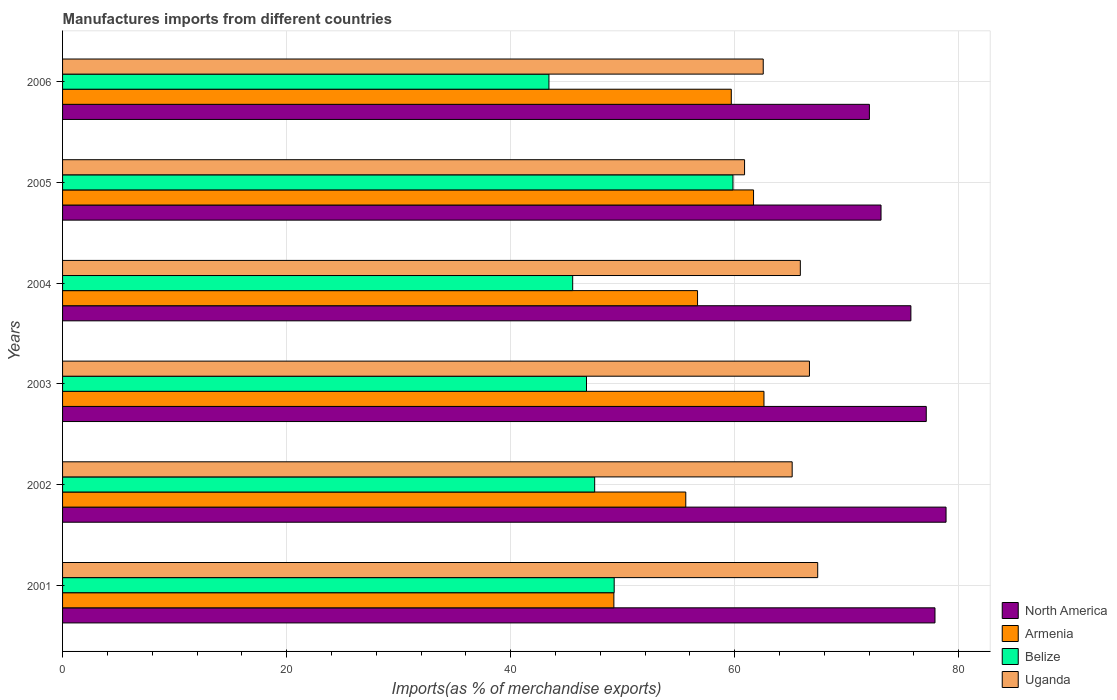How many different coloured bars are there?
Your answer should be compact. 4. How many groups of bars are there?
Ensure brevity in your answer.  6. What is the percentage of imports to different countries in Armenia in 2006?
Provide a short and direct response. 59.7. Across all years, what is the maximum percentage of imports to different countries in Armenia?
Offer a terse response. 62.61. Across all years, what is the minimum percentage of imports to different countries in North America?
Offer a very short reply. 72.02. In which year was the percentage of imports to different countries in Armenia maximum?
Ensure brevity in your answer.  2003. What is the total percentage of imports to different countries in Belize in the graph?
Your answer should be compact. 292.31. What is the difference between the percentage of imports to different countries in North America in 2003 and that in 2005?
Offer a terse response. 4.04. What is the difference between the percentage of imports to different countries in Uganda in 2005 and the percentage of imports to different countries in Armenia in 2002?
Offer a terse response. 5.25. What is the average percentage of imports to different countries in Belize per year?
Offer a terse response. 48.72. In the year 2004, what is the difference between the percentage of imports to different countries in North America and percentage of imports to different countries in Belize?
Your answer should be compact. 30.19. In how many years, is the percentage of imports to different countries in Belize greater than 12 %?
Your response must be concise. 6. What is the ratio of the percentage of imports to different countries in Uganda in 2002 to that in 2006?
Ensure brevity in your answer.  1.04. What is the difference between the highest and the second highest percentage of imports to different countries in Uganda?
Ensure brevity in your answer.  0.74. What is the difference between the highest and the lowest percentage of imports to different countries in Armenia?
Your answer should be very brief. 13.4. In how many years, is the percentage of imports to different countries in North America greater than the average percentage of imports to different countries in North America taken over all years?
Your answer should be compact. 3. What does the 2nd bar from the top in 2005 represents?
Ensure brevity in your answer.  Belize. What does the 1st bar from the bottom in 2005 represents?
Ensure brevity in your answer.  North America. Is it the case that in every year, the sum of the percentage of imports to different countries in Belize and percentage of imports to different countries in Uganda is greater than the percentage of imports to different countries in Armenia?
Offer a terse response. Yes. Are all the bars in the graph horizontal?
Offer a very short reply. Yes. How many years are there in the graph?
Make the answer very short. 6. What is the difference between two consecutive major ticks on the X-axis?
Offer a terse response. 20. How many legend labels are there?
Your answer should be compact. 4. What is the title of the graph?
Provide a succinct answer. Manufactures imports from different countries. What is the label or title of the X-axis?
Provide a succinct answer. Imports(as % of merchandise exports). What is the label or title of the Y-axis?
Give a very brief answer. Years. What is the Imports(as % of merchandise exports) in North America in 2001?
Your answer should be compact. 77.88. What is the Imports(as % of merchandise exports) of Armenia in 2001?
Provide a short and direct response. 49.21. What is the Imports(as % of merchandise exports) in Belize in 2001?
Keep it short and to the point. 49.24. What is the Imports(as % of merchandise exports) in Uganda in 2001?
Your response must be concise. 67.41. What is the Imports(as % of merchandise exports) in North America in 2002?
Your answer should be compact. 78.87. What is the Imports(as % of merchandise exports) of Armenia in 2002?
Keep it short and to the point. 55.63. What is the Imports(as % of merchandise exports) of Belize in 2002?
Ensure brevity in your answer.  47.5. What is the Imports(as % of merchandise exports) of Uganda in 2002?
Offer a very short reply. 65.13. What is the Imports(as % of merchandise exports) in North America in 2003?
Provide a short and direct response. 77.1. What is the Imports(as % of merchandise exports) of Armenia in 2003?
Your answer should be compact. 62.61. What is the Imports(as % of merchandise exports) in Belize in 2003?
Provide a short and direct response. 46.77. What is the Imports(as % of merchandise exports) of Uganda in 2003?
Keep it short and to the point. 66.67. What is the Imports(as % of merchandise exports) of North America in 2004?
Offer a very short reply. 75.73. What is the Imports(as % of merchandise exports) in Armenia in 2004?
Give a very brief answer. 56.68. What is the Imports(as % of merchandise exports) of Belize in 2004?
Your answer should be very brief. 45.54. What is the Imports(as % of merchandise exports) of Uganda in 2004?
Ensure brevity in your answer.  65.86. What is the Imports(as % of merchandise exports) of North America in 2005?
Keep it short and to the point. 73.06. What is the Imports(as % of merchandise exports) in Armenia in 2005?
Your answer should be compact. 61.68. What is the Imports(as % of merchandise exports) of Belize in 2005?
Your answer should be very brief. 59.85. What is the Imports(as % of merchandise exports) in Uganda in 2005?
Offer a terse response. 60.88. What is the Imports(as % of merchandise exports) in North America in 2006?
Give a very brief answer. 72.02. What is the Imports(as % of merchandise exports) in Armenia in 2006?
Your response must be concise. 59.7. What is the Imports(as % of merchandise exports) in Belize in 2006?
Your answer should be compact. 43.42. What is the Imports(as % of merchandise exports) of Uganda in 2006?
Your response must be concise. 62.55. Across all years, what is the maximum Imports(as % of merchandise exports) in North America?
Your answer should be compact. 78.87. Across all years, what is the maximum Imports(as % of merchandise exports) of Armenia?
Offer a terse response. 62.61. Across all years, what is the maximum Imports(as % of merchandise exports) of Belize?
Provide a succinct answer. 59.85. Across all years, what is the maximum Imports(as % of merchandise exports) in Uganda?
Your answer should be compact. 67.41. Across all years, what is the minimum Imports(as % of merchandise exports) in North America?
Your response must be concise. 72.02. Across all years, what is the minimum Imports(as % of merchandise exports) in Armenia?
Offer a very short reply. 49.21. Across all years, what is the minimum Imports(as % of merchandise exports) in Belize?
Offer a terse response. 43.42. Across all years, what is the minimum Imports(as % of merchandise exports) in Uganda?
Provide a short and direct response. 60.88. What is the total Imports(as % of merchandise exports) of North America in the graph?
Offer a terse response. 454.66. What is the total Imports(as % of merchandise exports) of Armenia in the graph?
Make the answer very short. 345.52. What is the total Imports(as % of merchandise exports) of Belize in the graph?
Provide a succinct answer. 292.31. What is the total Imports(as % of merchandise exports) in Uganda in the graph?
Your response must be concise. 388.5. What is the difference between the Imports(as % of merchandise exports) of North America in 2001 and that in 2002?
Your answer should be compact. -0.99. What is the difference between the Imports(as % of merchandise exports) of Armenia in 2001 and that in 2002?
Offer a very short reply. -6.42. What is the difference between the Imports(as % of merchandise exports) of Belize in 2001 and that in 2002?
Make the answer very short. 1.74. What is the difference between the Imports(as % of merchandise exports) in Uganda in 2001 and that in 2002?
Your answer should be compact. 2.28. What is the difference between the Imports(as % of merchandise exports) in North America in 2001 and that in 2003?
Provide a short and direct response. 0.78. What is the difference between the Imports(as % of merchandise exports) of Armenia in 2001 and that in 2003?
Your response must be concise. -13.4. What is the difference between the Imports(as % of merchandise exports) of Belize in 2001 and that in 2003?
Offer a very short reply. 2.47. What is the difference between the Imports(as % of merchandise exports) of Uganda in 2001 and that in 2003?
Your response must be concise. 0.74. What is the difference between the Imports(as % of merchandise exports) of North America in 2001 and that in 2004?
Offer a very short reply. 2.15. What is the difference between the Imports(as % of merchandise exports) in Armenia in 2001 and that in 2004?
Your response must be concise. -7.47. What is the difference between the Imports(as % of merchandise exports) of Belize in 2001 and that in 2004?
Your answer should be very brief. 3.71. What is the difference between the Imports(as % of merchandise exports) of Uganda in 2001 and that in 2004?
Offer a terse response. 1.55. What is the difference between the Imports(as % of merchandise exports) of North America in 2001 and that in 2005?
Your answer should be very brief. 4.82. What is the difference between the Imports(as % of merchandise exports) of Armenia in 2001 and that in 2005?
Offer a very short reply. -12.47. What is the difference between the Imports(as % of merchandise exports) in Belize in 2001 and that in 2005?
Ensure brevity in your answer.  -10.6. What is the difference between the Imports(as % of merchandise exports) in Uganda in 2001 and that in 2005?
Offer a terse response. 6.53. What is the difference between the Imports(as % of merchandise exports) in North America in 2001 and that in 2006?
Offer a very short reply. 5.85. What is the difference between the Imports(as % of merchandise exports) in Armenia in 2001 and that in 2006?
Offer a very short reply. -10.48. What is the difference between the Imports(as % of merchandise exports) in Belize in 2001 and that in 2006?
Offer a terse response. 5.83. What is the difference between the Imports(as % of merchandise exports) in Uganda in 2001 and that in 2006?
Give a very brief answer. 4.86. What is the difference between the Imports(as % of merchandise exports) in North America in 2002 and that in 2003?
Provide a short and direct response. 1.77. What is the difference between the Imports(as % of merchandise exports) in Armenia in 2002 and that in 2003?
Make the answer very short. -6.98. What is the difference between the Imports(as % of merchandise exports) of Belize in 2002 and that in 2003?
Ensure brevity in your answer.  0.73. What is the difference between the Imports(as % of merchandise exports) in Uganda in 2002 and that in 2003?
Your answer should be very brief. -1.54. What is the difference between the Imports(as % of merchandise exports) in North America in 2002 and that in 2004?
Offer a very short reply. 3.14. What is the difference between the Imports(as % of merchandise exports) in Armenia in 2002 and that in 2004?
Make the answer very short. -1.05. What is the difference between the Imports(as % of merchandise exports) in Belize in 2002 and that in 2004?
Offer a terse response. 1.96. What is the difference between the Imports(as % of merchandise exports) of Uganda in 2002 and that in 2004?
Your answer should be very brief. -0.73. What is the difference between the Imports(as % of merchandise exports) in North America in 2002 and that in 2005?
Your answer should be compact. 5.8. What is the difference between the Imports(as % of merchandise exports) in Armenia in 2002 and that in 2005?
Your answer should be very brief. -6.05. What is the difference between the Imports(as % of merchandise exports) of Belize in 2002 and that in 2005?
Give a very brief answer. -12.34. What is the difference between the Imports(as % of merchandise exports) of Uganda in 2002 and that in 2005?
Provide a succinct answer. 4.25. What is the difference between the Imports(as % of merchandise exports) of North America in 2002 and that in 2006?
Offer a terse response. 6.84. What is the difference between the Imports(as % of merchandise exports) of Armenia in 2002 and that in 2006?
Give a very brief answer. -4.06. What is the difference between the Imports(as % of merchandise exports) of Belize in 2002 and that in 2006?
Ensure brevity in your answer.  4.08. What is the difference between the Imports(as % of merchandise exports) of Uganda in 2002 and that in 2006?
Give a very brief answer. 2.58. What is the difference between the Imports(as % of merchandise exports) in North America in 2003 and that in 2004?
Keep it short and to the point. 1.37. What is the difference between the Imports(as % of merchandise exports) of Armenia in 2003 and that in 2004?
Offer a terse response. 5.93. What is the difference between the Imports(as % of merchandise exports) of Belize in 2003 and that in 2004?
Your response must be concise. 1.23. What is the difference between the Imports(as % of merchandise exports) of Uganda in 2003 and that in 2004?
Give a very brief answer. 0.82. What is the difference between the Imports(as % of merchandise exports) in North America in 2003 and that in 2005?
Provide a short and direct response. 4.04. What is the difference between the Imports(as % of merchandise exports) of Armenia in 2003 and that in 2005?
Your answer should be compact. 0.93. What is the difference between the Imports(as % of merchandise exports) of Belize in 2003 and that in 2005?
Offer a terse response. -13.07. What is the difference between the Imports(as % of merchandise exports) in Uganda in 2003 and that in 2005?
Your answer should be compact. 5.79. What is the difference between the Imports(as % of merchandise exports) of North America in 2003 and that in 2006?
Give a very brief answer. 5.08. What is the difference between the Imports(as % of merchandise exports) in Armenia in 2003 and that in 2006?
Offer a terse response. 2.92. What is the difference between the Imports(as % of merchandise exports) of Belize in 2003 and that in 2006?
Offer a very short reply. 3.35. What is the difference between the Imports(as % of merchandise exports) in Uganda in 2003 and that in 2006?
Ensure brevity in your answer.  4.13. What is the difference between the Imports(as % of merchandise exports) of North America in 2004 and that in 2005?
Offer a very short reply. 2.67. What is the difference between the Imports(as % of merchandise exports) in Armenia in 2004 and that in 2005?
Give a very brief answer. -5. What is the difference between the Imports(as % of merchandise exports) in Belize in 2004 and that in 2005?
Offer a very short reply. -14.31. What is the difference between the Imports(as % of merchandise exports) of Uganda in 2004 and that in 2005?
Keep it short and to the point. 4.98. What is the difference between the Imports(as % of merchandise exports) of North America in 2004 and that in 2006?
Offer a terse response. 3.7. What is the difference between the Imports(as % of merchandise exports) of Armenia in 2004 and that in 2006?
Provide a succinct answer. -3.01. What is the difference between the Imports(as % of merchandise exports) of Belize in 2004 and that in 2006?
Your response must be concise. 2.12. What is the difference between the Imports(as % of merchandise exports) in Uganda in 2004 and that in 2006?
Provide a succinct answer. 3.31. What is the difference between the Imports(as % of merchandise exports) of North America in 2005 and that in 2006?
Make the answer very short. 1.04. What is the difference between the Imports(as % of merchandise exports) in Armenia in 2005 and that in 2006?
Provide a short and direct response. 1.99. What is the difference between the Imports(as % of merchandise exports) in Belize in 2005 and that in 2006?
Provide a succinct answer. 16.43. What is the difference between the Imports(as % of merchandise exports) in Uganda in 2005 and that in 2006?
Offer a terse response. -1.67. What is the difference between the Imports(as % of merchandise exports) of North America in 2001 and the Imports(as % of merchandise exports) of Armenia in 2002?
Give a very brief answer. 22.25. What is the difference between the Imports(as % of merchandise exports) in North America in 2001 and the Imports(as % of merchandise exports) in Belize in 2002?
Ensure brevity in your answer.  30.38. What is the difference between the Imports(as % of merchandise exports) in North America in 2001 and the Imports(as % of merchandise exports) in Uganda in 2002?
Provide a short and direct response. 12.75. What is the difference between the Imports(as % of merchandise exports) in Armenia in 2001 and the Imports(as % of merchandise exports) in Belize in 2002?
Keep it short and to the point. 1.71. What is the difference between the Imports(as % of merchandise exports) in Armenia in 2001 and the Imports(as % of merchandise exports) in Uganda in 2002?
Provide a short and direct response. -15.92. What is the difference between the Imports(as % of merchandise exports) in Belize in 2001 and the Imports(as % of merchandise exports) in Uganda in 2002?
Make the answer very short. -15.89. What is the difference between the Imports(as % of merchandise exports) in North America in 2001 and the Imports(as % of merchandise exports) in Armenia in 2003?
Ensure brevity in your answer.  15.27. What is the difference between the Imports(as % of merchandise exports) in North America in 2001 and the Imports(as % of merchandise exports) in Belize in 2003?
Offer a very short reply. 31.11. What is the difference between the Imports(as % of merchandise exports) in North America in 2001 and the Imports(as % of merchandise exports) in Uganda in 2003?
Your answer should be very brief. 11.21. What is the difference between the Imports(as % of merchandise exports) of Armenia in 2001 and the Imports(as % of merchandise exports) of Belize in 2003?
Your response must be concise. 2.44. What is the difference between the Imports(as % of merchandise exports) of Armenia in 2001 and the Imports(as % of merchandise exports) of Uganda in 2003?
Keep it short and to the point. -17.46. What is the difference between the Imports(as % of merchandise exports) of Belize in 2001 and the Imports(as % of merchandise exports) of Uganda in 2003?
Keep it short and to the point. -17.43. What is the difference between the Imports(as % of merchandise exports) of North America in 2001 and the Imports(as % of merchandise exports) of Armenia in 2004?
Your answer should be compact. 21.2. What is the difference between the Imports(as % of merchandise exports) in North America in 2001 and the Imports(as % of merchandise exports) in Belize in 2004?
Provide a short and direct response. 32.34. What is the difference between the Imports(as % of merchandise exports) in North America in 2001 and the Imports(as % of merchandise exports) in Uganda in 2004?
Keep it short and to the point. 12.02. What is the difference between the Imports(as % of merchandise exports) in Armenia in 2001 and the Imports(as % of merchandise exports) in Belize in 2004?
Your answer should be very brief. 3.68. What is the difference between the Imports(as % of merchandise exports) in Armenia in 2001 and the Imports(as % of merchandise exports) in Uganda in 2004?
Give a very brief answer. -16.64. What is the difference between the Imports(as % of merchandise exports) of Belize in 2001 and the Imports(as % of merchandise exports) of Uganda in 2004?
Ensure brevity in your answer.  -16.62. What is the difference between the Imports(as % of merchandise exports) in North America in 2001 and the Imports(as % of merchandise exports) in Armenia in 2005?
Provide a succinct answer. 16.2. What is the difference between the Imports(as % of merchandise exports) in North America in 2001 and the Imports(as % of merchandise exports) in Belize in 2005?
Make the answer very short. 18.03. What is the difference between the Imports(as % of merchandise exports) in North America in 2001 and the Imports(as % of merchandise exports) in Uganda in 2005?
Ensure brevity in your answer.  17. What is the difference between the Imports(as % of merchandise exports) in Armenia in 2001 and the Imports(as % of merchandise exports) in Belize in 2005?
Keep it short and to the point. -10.63. What is the difference between the Imports(as % of merchandise exports) of Armenia in 2001 and the Imports(as % of merchandise exports) of Uganda in 2005?
Offer a terse response. -11.67. What is the difference between the Imports(as % of merchandise exports) of Belize in 2001 and the Imports(as % of merchandise exports) of Uganda in 2005?
Your answer should be compact. -11.64. What is the difference between the Imports(as % of merchandise exports) of North America in 2001 and the Imports(as % of merchandise exports) of Armenia in 2006?
Make the answer very short. 18.18. What is the difference between the Imports(as % of merchandise exports) of North America in 2001 and the Imports(as % of merchandise exports) of Belize in 2006?
Your answer should be compact. 34.46. What is the difference between the Imports(as % of merchandise exports) of North America in 2001 and the Imports(as % of merchandise exports) of Uganda in 2006?
Provide a succinct answer. 15.33. What is the difference between the Imports(as % of merchandise exports) of Armenia in 2001 and the Imports(as % of merchandise exports) of Belize in 2006?
Offer a very short reply. 5.8. What is the difference between the Imports(as % of merchandise exports) in Armenia in 2001 and the Imports(as % of merchandise exports) in Uganda in 2006?
Make the answer very short. -13.33. What is the difference between the Imports(as % of merchandise exports) in Belize in 2001 and the Imports(as % of merchandise exports) in Uganda in 2006?
Offer a terse response. -13.3. What is the difference between the Imports(as % of merchandise exports) of North America in 2002 and the Imports(as % of merchandise exports) of Armenia in 2003?
Your answer should be compact. 16.25. What is the difference between the Imports(as % of merchandise exports) of North America in 2002 and the Imports(as % of merchandise exports) of Belize in 2003?
Your answer should be very brief. 32.1. What is the difference between the Imports(as % of merchandise exports) in North America in 2002 and the Imports(as % of merchandise exports) in Uganda in 2003?
Provide a short and direct response. 12.19. What is the difference between the Imports(as % of merchandise exports) in Armenia in 2002 and the Imports(as % of merchandise exports) in Belize in 2003?
Your response must be concise. 8.86. What is the difference between the Imports(as % of merchandise exports) of Armenia in 2002 and the Imports(as % of merchandise exports) of Uganda in 2003?
Provide a short and direct response. -11.04. What is the difference between the Imports(as % of merchandise exports) of Belize in 2002 and the Imports(as % of merchandise exports) of Uganda in 2003?
Ensure brevity in your answer.  -19.17. What is the difference between the Imports(as % of merchandise exports) of North America in 2002 and the Imports(as % of merchandise exports) of Armenia in 2004?
Offer a very short reply. 22.18. What is the difference between the Imports(as % of merchandise exports) of North America in 2002 and the Imports(as % of merchandise exports) of Belize in 2004?
Your answer should be compact. 33.33. What is the difference between the Imports(as % of merchandise exports) in North America in 2002 and the Imports(as % of merchandise exports) in Uganda in 2004?
Make the answer very short. 13.01. What is the difference between the Imports(as % of merchandise exports) in Armenia in 2002 and the Imports(as % of merchandise exports) in Belize in 2004?
Offer a very short reply. 10.1. What is the difference between the Imports(as % of merchandise exports) of Armenia in 2002 and the Imports(as % of merchandise exports) of Uganda in 2004?
Your response must be concise. -10.23. What is the difference between the Imports(as % of merchandise exports) of Belize in 2002 and the Imports(as % of merchandise exports) of Uganda in 2004?
Your response must be concise. -18.36. What is the difference between the Imports(as % of merchandise exports) in North America in 2002 and the Imports(as % of merchandise exports) in Armenia in 2005?
Make the answer very short. 17.18. What is the difference between the Imports(as % of merchandise exports) of North America in 2002 and the Imports(as % of merchandise exports) of Belize in 2005?
Keep it short and to the point. 19.02. What is the difference between the Imports(as % of merchandise exports) of North America in 2002 and the Imports(as % of merchandise exports) of Uganda in 2005?
Ensure brevity in your answer.  17.99. What is the difference between the Imports(as % of merchandise exports) in Armenia in 2002 and the Imports(as % of merchandise exports) in Belize in 2005?
Make the answer very short. -4.21. What is the difference between the Imports(as % of merchandise exports) in Armenia in 2002 and the Imports(as % of merchandise exports) in Uganda in 2005?
Provide a short and direct response. -5.25. What is the difference between the Imports(as % of merchandise exports) of Belize in 2002 and the Imports(as % of merchandise exports) of Uganda in 2005?
Provide a succinct answer. -13.38. What is the difference between the Imports(as % of merchandise exports) in North America in 2002 and the Imports(as % of merchandise exports) in Armenia in 2006?
Offer a terse response. 19.17. What is the difference between the Imports(as % of merchandise exports) in North America in 2002 and the Imports(as % of merchandise exports) in Belize in 2006?
Provide a short and direct response. 35.45. What is the difference between the Imports(as % of merchandise exports) in North America in 2002 and the Imports(as % of merchandise exports) in Uganda in 2006?
Provide a succinct answer. 16.32. What is the difference between the Imports(as % of merchandise exports) in Armenia in 2002 and the Imports(as % of merchandise exports) in Belize in 2006?
Your response must be concise. 12.22. What is the difference between the Imports(as % of merchandise exports) of Armenia in 2002 and the Imports(as % of merchandise exports) of Uganda in 2006?
Provide a succinct answer. -6.91. What is the difference between the Imports(as % of merchandise exports) of Belize in 2002 and the Imports(as % of merchandise exports) of Uganda in 2006?
Keep it short and to the point. -15.05. What is the difference between the Imports(as % of merchandise exports) in North America in 2003 and the Imports(as % of merchandise exports) in Armenia in 2004?
Offer a very short reply. 20.42. What is the difference between the Imports(as % of merchandise exports) of North America in 2003 and the Imports(as % of merchandise exports) of Belize in 2004?
Offer a terse response. 31.56. What is the difference between the Imports(as % of merchandise exports) in North America in 2003 and the Imports(as % of merchandise exports) in Uganda in 2004?
Your answer should be very brief. 11.24. What is the difference between the Imports(as % of merchandise exports) in Armenia in 2003 and the Imports(as % of merchandise exports) in Belize in 2004?
Your answer should be very brief. 17.08. What is the difference between the Imports(as % of merchandise exports) of Armenia in 2003 and the Imports(as % of merchandise exports) of Uganda in 2004?
Your response must be concise. -3.24. What is the difference between the Imports(as % of merchandise exports) of Belize in 2003 and the Imports(as % of merchandise exports) of Uganda in 2004?
Your response must be concise. -19.09. What is the difference between the Imports(as % of merchandise exports) in North America in 2003 and the Imports(as % of merchandise exports) in Armenia in 2005?
Your response must be concise. 15.42. What is the difference between the Imports(as % of merchandise exports) in North America in 2003 and the Imports(as % of merchandise exports) in Belize in 2005?
Make the answer very short. 17.26. What is the difference between the Imports(as % of merchandise exports) in North America in 2003 and the Imports(as % of merchandise exports) in Uganda in 2005?
Your answer should be compact. 16.22. What is the difference between the Imports(as % of merchandise exports) in Armenia in 2003 and the Imports(as % of merchandise exports) in Belize in 2005?
Your response must be concise. 2.77. What is the difference between the Imports(as % of merchandise exports) of Armenia in 2003 and the Imports(as % of merchandise exports) of Uganda in 2005?
Provide a succinct answer. 1.73. What is the difference between the Imports(as % of merchandise exports) in Belize in 2003 and the Imports(as % of merchandise exports) in Uganda in 2005?
Offer a terse response. -14.11. What is the difference between the Imports(as % of merchandise exports) in North America in 2003 and the Imports(as % of merchandise exports) in Armenia in 2006?
Give a very brief answer. 17.4. What is the difference between the Imports(as % of merchandise exports) of North America in 2003 and the Imports(as % of merchandise exports) of Belize in 2006?
Your response must be concise. 33.68. What is the difference between the Imports(as % of merchandise exports) of North America in 2003 and the Imports(as % of merchandise exports) of Uganda in 2006?
Make the answer very short. 14.55. What is the difference between the Imports(as % of merchandise exports) of Armenia in 2003 and the Imports(as % of merchandise exports) of Belize in 2006?
Make the answer very short. 19.2. What is the difference between the Imports(as % of merchandise exports) in Armenia in 2003 and the Imports(as % of merchandise exports) in Uganda in 2006?
Your answer should be very brief. 0.07. What is the difference between the Imports(as % of merchandise exports) of Belize in 2003 and the Imports(as % of merchandise exports) of Uganda in 2006?
Ensure brevity in your answer.  -15.78. What is the difference between the Imports(as % of merchandise exports) in North America in 2004 and the Imports(as % of merchandise exports) in Armenia in 2005?
Ensure brevity in your answer.  14.05. What is the difference between the Imports(as % of merchandise exports) of North America in 2004 and the Imports(as % of merchandise exports) of Belize in 2005?
Make the answer very short. 15.88. What is the difference between the Imports(as % of merchandise exports) in North America in 2004 and the Imports(as % of merchandise exports) in Uganda in 2005?
Your answer should be very brief. 14.85. What is the difference between the Imports(as % of merchandise exports) in Armenia in 2004 and the Imports(as % of merchandise exports) in Belize in 2005?
Your answer should be very brief. -3.16. What is the difference between the Imports(as % of merchandise exports) of Armenia in 2004 and the Imports(as % of merchandise exports) of Uganda in 2005?
Give a very brief answer. -4.2. What is the difference between the Imports(as % of merchandise exports) in Belize in 2004 and the Imports(as % of merchandise exports) in Uganda in 2005?
Provide a short and direct response. -15.34. What is the difference between the Imports(as % of merchandise exports) in North America in 2004 and the Imports(as % of merchandise exports) in Armenia in 2006?
Keep it short and to the point. 16.03. What is the difference between the Imports(as % of merchandise exports) in North America in 2004 and the Imports(as % of merchandise exports) in Belize in 2006?
Provide a succinct answer. 32.31. What is the difference between the Imports(as % of merchandise exports) of North America in 2004 and the Imports(as % of merchandise exports) of Uganda in 2006?
Offer a very short reply. 13.18. What is the difference between the Imports(as % of merchandise exports) in Armenia in 2004 and the Imports(as % of merchandise exports) in Belize in 2006?
Make the answer very short. 13.27. What is the difference between the Imports(as % of merchandise exports) of Armenia in 2004 and the Imports(as % of merchandise exports) of Uganda in 2006?
Make the answer very short. -5.86. What is the difference between the Imports(as % of merchandise exports) of Belize in 2004 and the Imports(as % of merchandise exports) of Uganda in 2006?
Provide a short and direct response. -17.01. What is the difference between the Imports(as % of merchandise exports) of North America in 2005 and the Imports(as % of merchandise exports) of Armenia in 2006?
Offer a terse response. 13.37. What is the difference between the Imports(as % of merchandise exports) of North America in 2005 and the Imports(as % of merchandise exports) of Belize in 2006?
Keep it short and to the point. 29.65. What is the difference between the Imports(as % of merchandise exports) in North America in 2005 and the Imports(as % of merchandise exports) in Uganda in 2006?
Your answer should be very brief. 10.52. What is the difference between the Imports(as % of merchandise exports) in Armenia in 2005 and the Imports(as % of merchandise exports) in Belize in 2006?
Give a very brief answer. 18.26. What is the difference between the Imports(as % of merchandise exports) of Armenia in 2005 and the Imports(as % of merchandise exports) of Uganda in 2006?
Offer a very short reply. -0.87. What is the difference between the Imports(as % of merchandise exports) in Belize in 2005 and the Imports(as % of merchandise exports) in Uganda in 2006?
Make the answer very short. -2.7. What is the average Imports(as % of merchandise exports) of North America per year?
Offer a terse response. 75.78. What is the average Imports(as % of merchandise exports) in Armenia per year?
Your response must be concise. 57.59. What is the average Imports(as % of merchandise exports) of Belize per year?
Your answer should be compact. 48.72. What is the average Imports(as % of merchandise exports) in Uganda per year?
Your answer should be compact. 64.75. In the year 2001, what is the difference between the Imports(as % of merchandise exports) of North America and Imports(as % of merchandise exports) of Armenia?
Your answer should be very brief. 28.66. In the year 2001, what is the difference between the Imports(as % of merchandise exports) in North America and Imports(as % of merchandise exports) in Belize?
Provide a succinct answer. 28.64. In the year 2001, what is the difference between the Imports(as % of merchandise exports) in North America and Imports(as % of merchandise exports) in Uganda?
Your response must be concise. 10.47. In the year 2001, what is the difference between the Imports(as % of merchandise exports) in Armenia and Imports(as % of merchandise exports) in Belize?
Provide a short and direct response. -0.03. In the year 2001, what is the difference between the Imports(as % of merchandise exports) of Armenia and Imports(as % of merchandise exports) of Uganda?
Your answer should be compact. -18.19. In the year 2001, what is the difference between the Imports(as % of merchandise exports) in Belize and Imports(as % of merchandise exports) in Uganda?
Your answer should be very brief. -18.17. In the year 2002, what is the difference between the Imports(as % of merchandise exports) of North America and Imports(as % of merchandise exports) of Armenia?
Offer a very short reply. 23.23. In the year 2002, what is the difference between the Imports(as % of merchandise exports) in North America and Imports(as % of merchandise exports) in Belize?
Your answer should be compact. 31.37. In the year 2002, what is the difference between the Imports(as % of merchandise exports) of North America and Imports(as % of merchandise exports) of Uganda?
Your answer should be very brief. 13.74. In the year 2002, what is the difference between the Imports(as % of merchandise exports) of Armenia and Imports(as % of merchandise exports) of Belize?
Keep it short and to the point. 8.13. In the year 2002, what is the difference between the Imports(as % of merchandise exports) in Armenia and Imports(as % of merchandise exports) in Uganda?
Provide a succinct answer. -9.5. In the year 2002, what is the difference between the Imports(as % of merchandise exports) in Belize and Imports(as % of merchandise exports) in Uganda?
Your response must be concise. -17.63. In the year 2003, what is the difference between the Imports(as % of merchandise exports) of North America and Imports(as % of merchandise exports) of Armenia?
Make the answer very short. 14.49. In the year 2003, what is the difference between the Imports(as % of merchandise exports) of North America and Imports(as % of merchandise exports) of Belize?
Your response must be concise. 30.33. In the year 2003, what is the difference between the Imports(as % of merchandise exports) of North America and Imports(as % of merchandise exports) of Uganda?
Ensure brevity in your answer.  10.43. In the year 2003, what is the difference between the Imports(as % of merchandise exports) of Armenia and Imports(as % of merchandise exports) of Belize?
Provide a short and direct response. 15.84. In the year 2003, what is the difference between the Imports(as % of merchandise exports) of Armenia and Imports(as % of merchandise exports) of Uganda?
Provide a succinct answer. -4.06. In the year 2003, what is the difference between the Imports(as % of merchandise exports) of Belize and Imports(as % of merchandise exports) of Uganda?
Make the answer very short. -19.9. In the year 2004, what is the difference between the Imports(as % of merchandise exports) in North America and Imports(as % of merchandise exports) in Armenia?
Give a very brief answer. 19.05. In the year 2004, what is the difference between the Imports(as % of merchandise exports) in North America and Imports(as % of merchandise exports) in Belize?
Keep it short and to the point. 30.19. In the year 2004, what is the difference between the Imports(as % of merchandise exports) in North America and Imports(as % of merchandise exports) in Uganda?
Keep it short and to the point. 9.87. In the year 2004, what is the difference between the Imports(as % of merchandise exports) of Armenia and Imports(as % of merchandise exports) of Belize?
Offer a very short reply. 11.15. In the year 2004, what is the difference between the Imports(as % of merchandise exports) of Armenia and Imports(as % of merchandise exports) of Uganda?
Provide a succinct answer. -9.18. In the year 2004, what is the difference between the Imports(as % of merchandise exports) of Belize and Imports(as % of merchandise exports) of Uganda?
Your answer should be very brief. -20.32. In the year 2005, what is the difference between the Imports(as % of merchandise exports) of North America and Imports(as % of merchandise exports) of Armenia?
Offer a very short reply. 11.38. In the year 2005, what is the difference between the Imports(as % of merchandise exports) of North America and Imports(as % of merchandise exports) of Belize?
Your answer should be compact. 13.22. In the year 2005, what is the difference between the Imports(as % of merchandise exports) in North America and Imports(as % of merchandise exports) in Uganda?
Your answer should be very brief. 12.18. In the year 2005, what is the difference between the Imports(as % of merchandise exports) of Armenia and Imports(as % of merchandise exports) of Belize?
Offer a terse response. 1.84. In the year 2005, what is the difference between the Imports(as % of merchandise exports) in Armenia and Imports(as % of merchandise exports) in Uganda?
Your response must be concise. 0.8. In the year 2005, what is the difference between the Imports(as % of merchandise exports) of Belize and Imports(as % of merchandise exports) of Uganda?
Provide a succinct answer. -1.04. In the year 2006, what is the difference between the Imports(as % of merchandise exports) of North America and Imports(as % of merchandise exports) of Armenia?
Your answer should be very brief. 12.33. In the year 2006, what is the difference between the Imports(as % of merchandise exports) of North America and Imports(as % of merchandise exports) of Belize?
Provide a succinct answer. 28.61. In the year 2006, what is the difference between the Imports(as % of merchandise exports) in North America and Imports(as % of merchandise exports) in Uganda?
Provide a succinct answer. 9.48. In the year 2006, what is the difference between the Imports(as % of merchandise exports) in Armenia and Imports(as % of merchandise exports) in Belize?
Make the answer very short. 16.28. In the year 2006, what is the difference between the Imports(as % of merchandise exports) in Armenia and Imports(as % of merchandise exports) in Uganda?
Your response must be concise. -2.85. In the year 2006, what is the difference between the Imports(as % of merchandise exports) in Belize and Imports(as % of merchandise exports) in Uganda?
Offer a very short reply. -19.13. What is the ratio of the Imports(as % of merchandise exports) of North America in 2001 to that in 2002?
Make the answer very short. 0.99. What is the ratio of the Imports(as % of merchandise exports) of Armenia in 2001 to that in 2002?
Your answer should be very brief. 0.88. What is the ratio of the Imports(as % of merchandise exports) of Belize in 2001 to that in 2002?
Your answer should be compact. 1.04. What is the ratio of the Imports(as % of merchandise exports) in Uganda in 2001 to that in 2002?
Provide a succinct answer. 1.03. What is the ratio of the Imports(as % of merchandise exports) in Armenia in 2001 to that in 2003?
Offer a very short reply. 0.79. What is the ratio of the Imports(as % of merchandise exports) in Belize in 2001 to that in 2003?
Keep it short and to the point. 1.05. What is the ratio of the Imports(as % of merchandise exports) in North America in 2001 to that in 2004?
Your answer should be very brief. 1.03. What is the ratio of the Imports(as % of merchandise exports) in Armenia in 2001 to that in 2004?
Your answer should be compact. 0.87. What is the ratio of the Imports(as % of merchandise exports) in Belize in 2001 to that in 2004?
Your response must be concise. 1.08. What is the ratio of the Imports(as % of merchandise exports) in Uganda in 2001 to that in 2004?
Ensure brevity in your answer.  1.02. What is the ratio of the Imports(as % of merchandise exports) of North America in 2001 to that in 2005?
Provide a succinct answer. 1.07. What is the ratio of the Imports(as % of merchandise exports) in Armenia in 2001 to that in 2005?
Your answer should be very brief. 0.8. What is the ratio of the Imports(as % of merchandise exports) of Belize in 2001 to that in 2005?
Provide a short and direct response. 0.82. What is the ratio of the Imports(as % of merchandise exports) of Uganda in 2001 to that in 2005?
Your response must be concise. 1.11. What is the ratio of the Imports(as % of merchandise exports) in North America in 2001 to that in 2006?
Offer a very short reply. 1.08. What is the ratio of the Imports(as % of merchandise exports) in Armenia in 2001 to that in 2006?
Provide a succinct answer. 0.82. What is the ratio of the Imports(as % of merchandise exports) of Belize in 2001 to that in 2006?
Ensure brevity in your answer.  1.13. What is the ratio of the Imports(as % of merchandise exports) in Uganda in 2001 to that in 2006?
Your response must be concise. 1.08. What is the ratio of the Imports(as % of merchandise exports) in North America in 2002 to that in 2003?
Provide a short and direct response. 1.02. What is the ratio of the Imports(as % of merchandise exports) in Armenia in 2002 to that in 2003?
Your answer should be compact. 0.89. What is the ratio of the Imports(as % of merchandise exports) of Belize in 2002 to that in 2003?
Ensure brevity in your answer.  1.02. What is the ratio of the Imports(as % of merchandise exports) in Uganda in 2002 to that in 2003?
Your answer should be compact. 0.98. What is the ratio of the Imports(as % of merchandise exports) in North America in 2002 to that in 2004?
Provide a short and direct response. 1.04. What is the ratio of the Imports(as % of merchandise exports) in Armenia in 2002 to that in 2004?
Ensure brevity in your answer.  0.98. What is the ratio of the Imports(as % of merchandise exports) of Belize in 2002 to that in 2004?
Offer a terse response. 1.04. What is the ratio of the Imports(as % of merchandise exports) in North America in 2002 to that in 2005?
Provide a succinct answer. 1.08. What is the ratio of the Imports(as % of merchandise exports) in Armenia in 2002 to that in 2005?
Keep it short and to the point. 0.9. What is the ratio of the Imports(as % of merchandise exports) in Belize in 2002 to that in 2005?
Your answer should be very brief. 0.79. What is the ratio of the Imports(as % of merchandise exports) in Uganda in 2002 to that in 2005?
Ensure brevity in your answer.  1.07. What is the ratio of the Imports(as % of merchandise exports) of North America in 2002 to that in 2006?
Offer a terse response. 1.09. What is the ratio of the Imports(as % of merchandise exports) of Armenia in 2002 to that in 2006?
Offer a very short reply. 0.93. What is the ratio of the Imports(as % of merchandise exports) of Belize in 2002 to that in 2006?
Your response must be concise. 1.09. What is the ratio of the Imports(as % of merchandise exports) of Uganda in 2002 to that in 2006?
Keep it short and to the point. 1.04. What is the ratio of the Imports(as % of merchandise exports) in North America in 2003 to that in 2004?
Offer a very short reply. 1.02. What is the ratio of the Imports(as % of merchandise exports) of Armenia in 2003 to that in 2004?
Provide a succinct answer. 1.1. What is the ratio of the Imports(as % of merchandise exports) in Belize in 2003 to that in 2004?
Make the answer very short. 1.03. What is the ratio of the Imports(as % of merchandise exports) of Uganda in 2003 to that in 2004?
Ensure brevity in your answer.  1.01. What is the ratio of the Imports(as % of merchandise exports) of North America in 2003 to that in 2005?
Offer a terse response. 1.06. What is the ratio of the Imports(as % of merchandise exports) of Armenia in 2003 to that in 2005?
Provide a succinct answer. 1.02. What is the ratio of the Imports(as % of merchandise exports) in Belize in 2003 to that in 2005?
Keep it short and to the point. 0.78. What is the ratio of the Imports(as % of merchandise exports) of Uganda in 2003 to that in 2005?
Offer a very short reply. 1.1. What is the ratio of the Imports(as % of merchandise exports) in North America in 2003 to that in 2006?
Ensure brevity in your answer.  1.07. What is the ratio of the Imports(as % of merchandise exports) of Armenia in 2003 to that in 2006?
Provide a succinct answer. 1.05. What is the ratio of the Imports(as % of merchandise exports) of Belize in 2003 to that in 2006?
Offer a terse response. 1.08. What is the ratio of the Imports(as % of merchandise exports) in Uganda in 2003 to that in 2006?
Give a very brief answer. 1.07. What is the ratio of the Imports(as % of merchandise exports) of North America in 2004 to that in 2005?
Provide a short and direct response. 1.04. What is the ratio of the Imports(as % of merchandise exports) in Armenia in 2004 to that in 2005?
Your answer should be compact. 0.92. What is the ratio of the Imports(as % of merchandise exports) of Belize in 2004 to that in 2005?
Your answer should be very brief. 0.76. What is the ratio of the Imports(as % of merchandise exports) in Uganda in 2004 to that in 2005?
Ensure brevity in your answer.  1.08. What is the ratio of the Imports(as % of merchandise exports) of North America in 2004 to that in 2006?
Your answer should be very brief. 1.05. What is the ratio of the Imports(as % of merchandise exports) of Armenia in 2004 to that in 2006?
Your answer should be compact. 0.95. What is the ratio of the Imports(as % of merchandise exports) in Belize in 2004 to that in 2006?
Provide a succinct answer. 1.05. What is the ratio of the Imports(as % of merchandise exports) in Uganda in 2004 to that in 2006?
Make the answer very short. 1.05. What is the ratio of the Imports(as % of merchandise exports) in North America in 2005 to that in 2006?
Provide a short and direct response. 1.01. What is the ratio of the Imports(as % of merchandise exports) of Belize in 2005 to that in 2006?
Make the answer very short. 1.38. What is the ratio of the Imports(as % of merchandise exports) in Uganda in 2005 to that in 2006?
Offer a very short reply. 0.97. What is the difference between the highest and the second highest Imports(as % of merchandise exports) in North America?
Your answer should be compact. 0.99. What is the difference between the highest and the second highest Imports(as % of merchandise exports) in Armenia?
Provide a succinct answer. 0.93. What is the difference between the highest and the second highest Imports(as % of merchandise exports) of Belize?
Offer a terse response. 10.6. What is the difference between the highest and the second highest Imports(as % of merchandise exports) in Uganda?
Give a very brief answer. 0.74. What is the difference between the highest and the lowest Imports(as % of merchandise exports) of North America?
Give a very brief answer. 6.84. What is the difference between the highest and the lowest Imports(as % of merchandise exports) of Armenia?
Provide a succinct answer. 13.4. What is the difference between the highest and the lowest Imports(as % of merchandise exports) in Belize?
Your response must be concise. 16.43. What is the difference between the highest and the lowest Imports(as % of merchandise exports) in Uganda?
Provide a short and direct response. 6.53. 